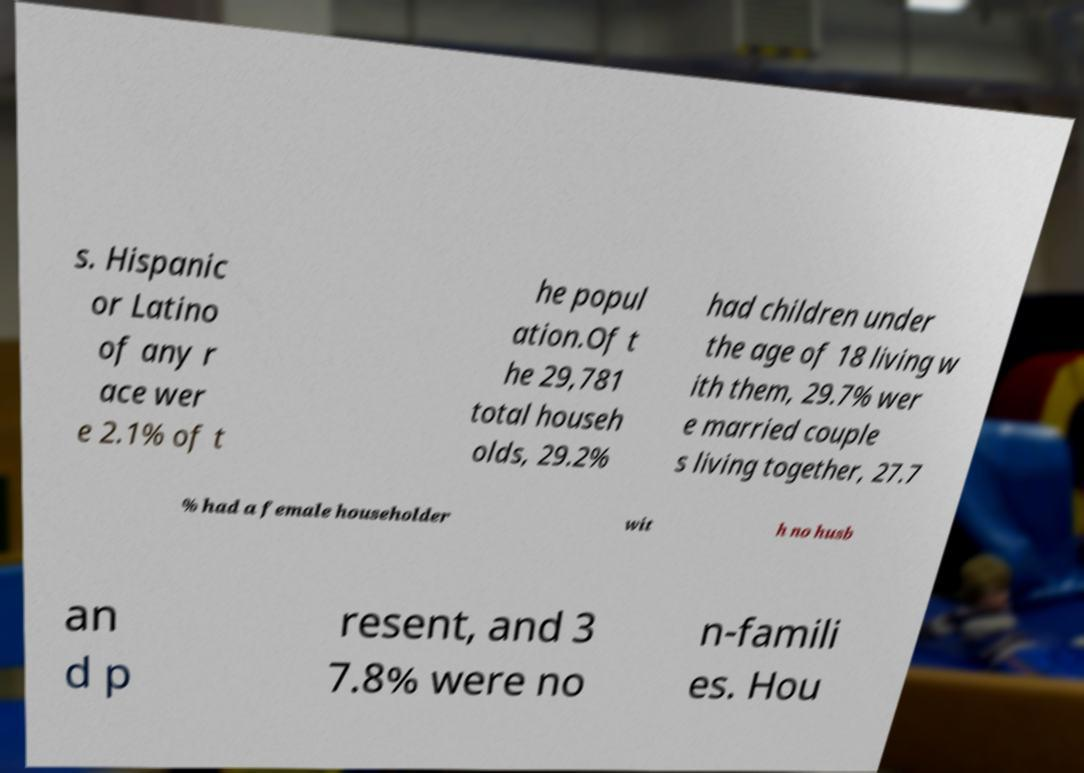Can you accurately transcribe the text from the provided image for me? s. Hispanic or Latino of any r ace wer e 2.1% of t he popul ation.Of t he 29,781 total househ olds, 29.2% had children under the age of 18 living w ith them, 29.7% wer e married couple s living together, 27.7 % had a female householder wit h no husb an d p resent, and 3 7.8% were no n-famili es. Hou 